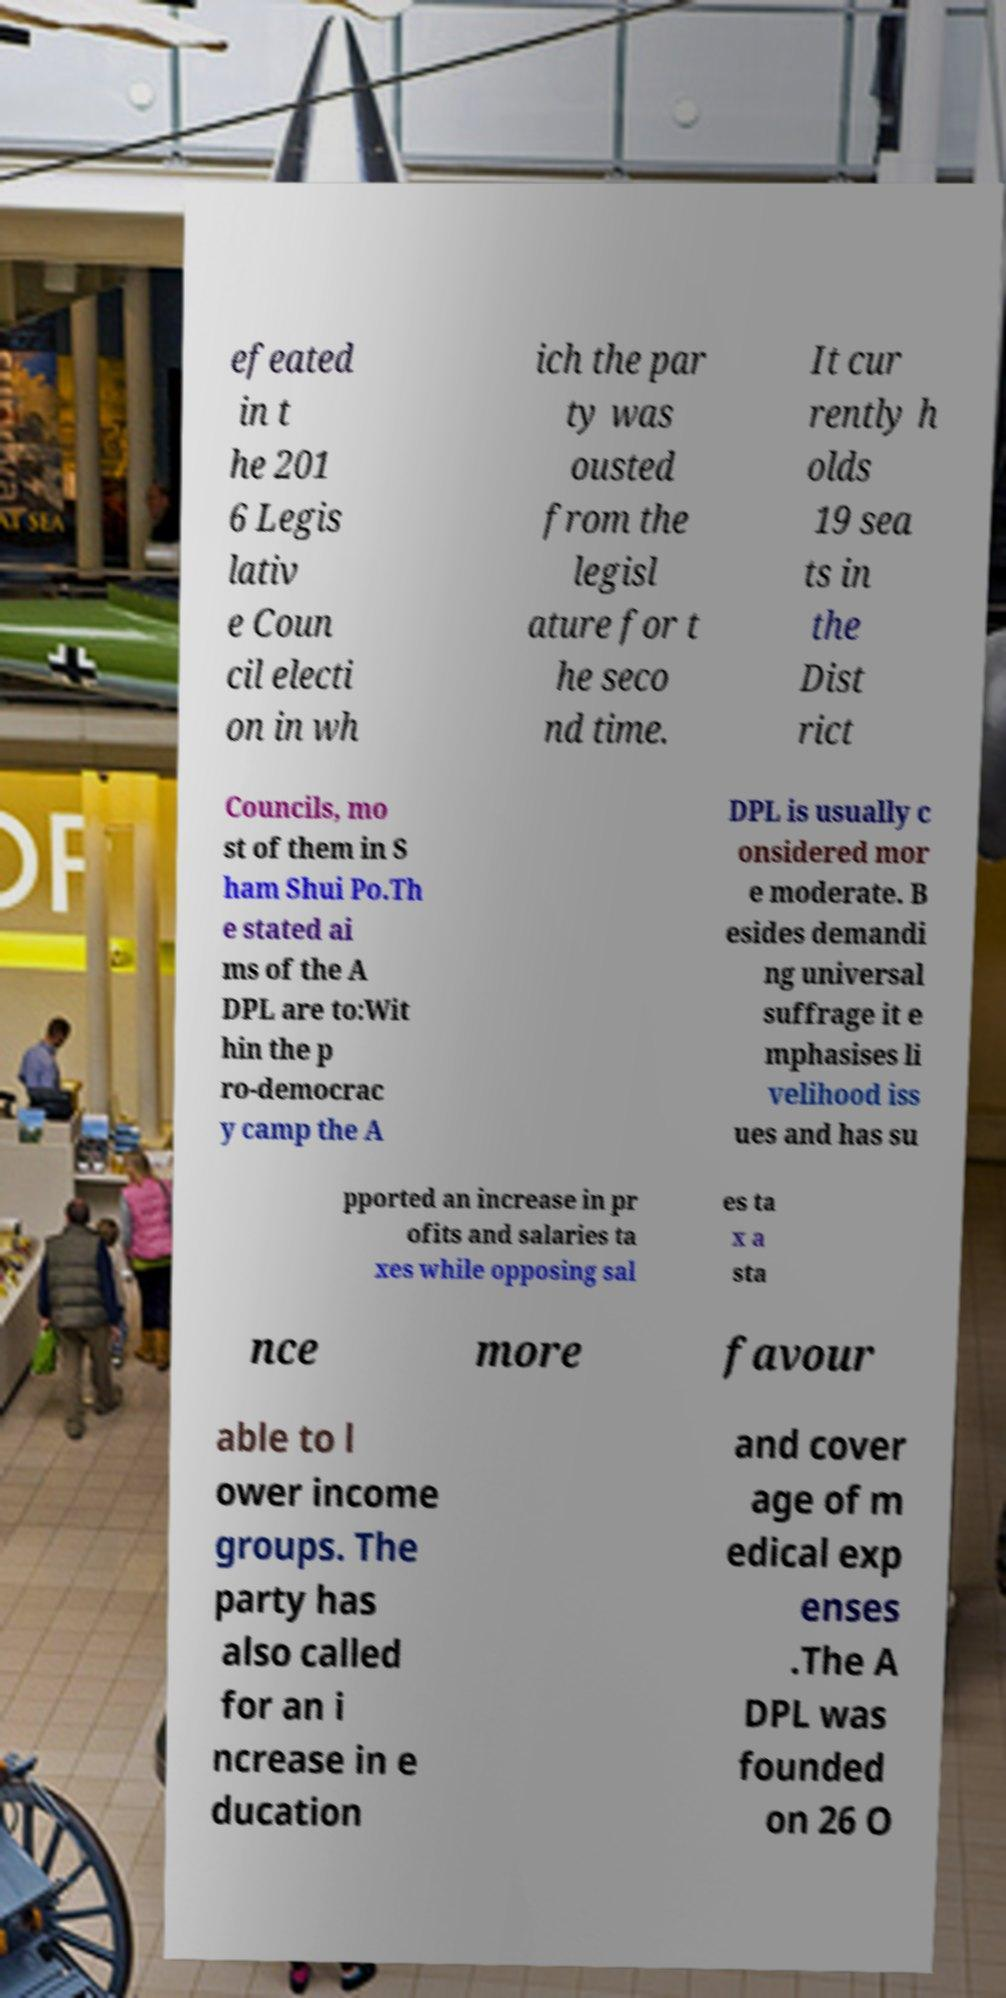Can you accurately transcribe the text from the provided image for me? efeated in t he 201 6 Legis lativ e Coun cil electi on in wh ich the par ty was ousted from the legisl ature for t he seco nd time. It cur rently h olds 19 sea ts in the Dist rict Councils, mo st of them in S ham Shui Po.Th e stated ai ms of the A DPL are to:Wit hin the p ro-democrac y camp the A DPL is usually c onsidered mor e moderate. B esides demandi ng universal suffrage it e mphasises li velihood iss ues and has su pported an increase in pr ofits and salaries ta xes while opposing sal es ta x a sta nce more favour able to l ower income groups. The party has also called for an i ncrease in e ducation and cover age of m edical exp enses .The A DPL was founded on 26 O 